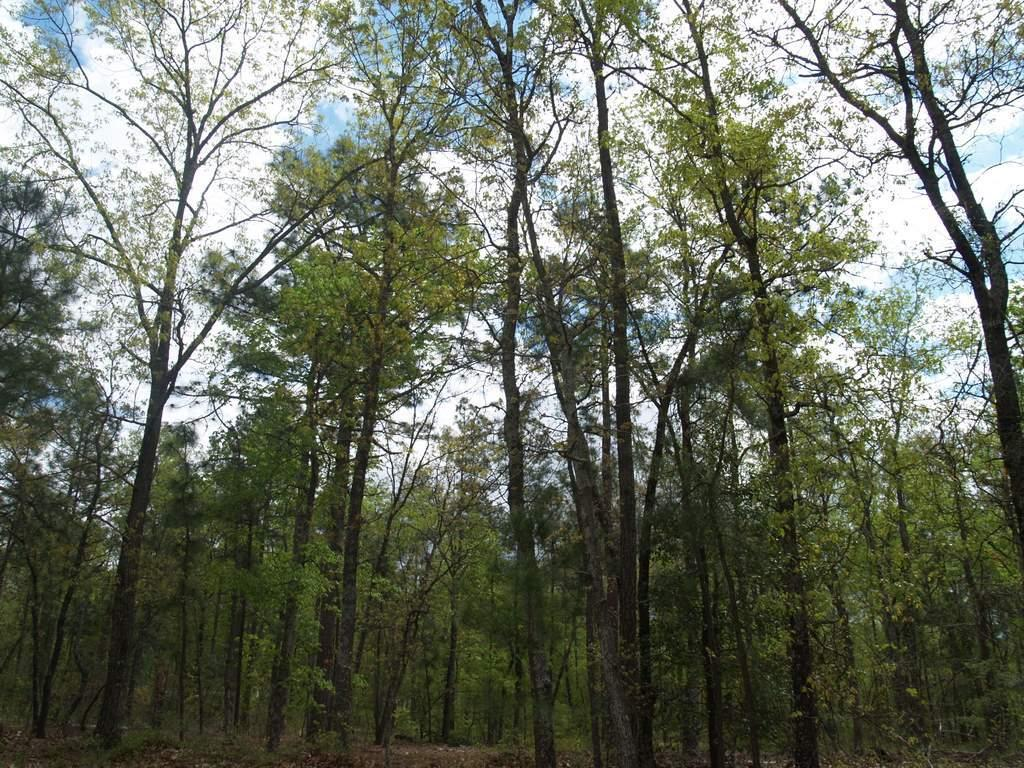What type of vegetation can be seen in the image? There are trees in the image. What is visible at the top of the image? The sky is visible at the top of the image. What can be observed in the sky? Clouds are present in the sky. What type of oil can be seen dripping from the trees in the image? There is no oil present in the image; it features trees and a sky with clouds. What color is the love symbolizing in the image? There is no symbol of love present in the image; it only features trees and a sky with clouds. 